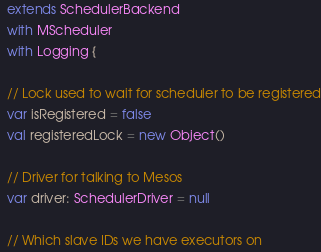<code> <loc_0><loc_0><loc_500><loc_500><_Scala_>  extends SchedulerBackend
  with MScheduler
  with Logging {

  // Lock used to wait for scheduler to be registered
  var isRegistered = false
  val registeredLock = new Object()

  // Driver for talking to Mesos
  var driver: SchedulerDriver = null

  // Which slave IDs we have executors on</code> 